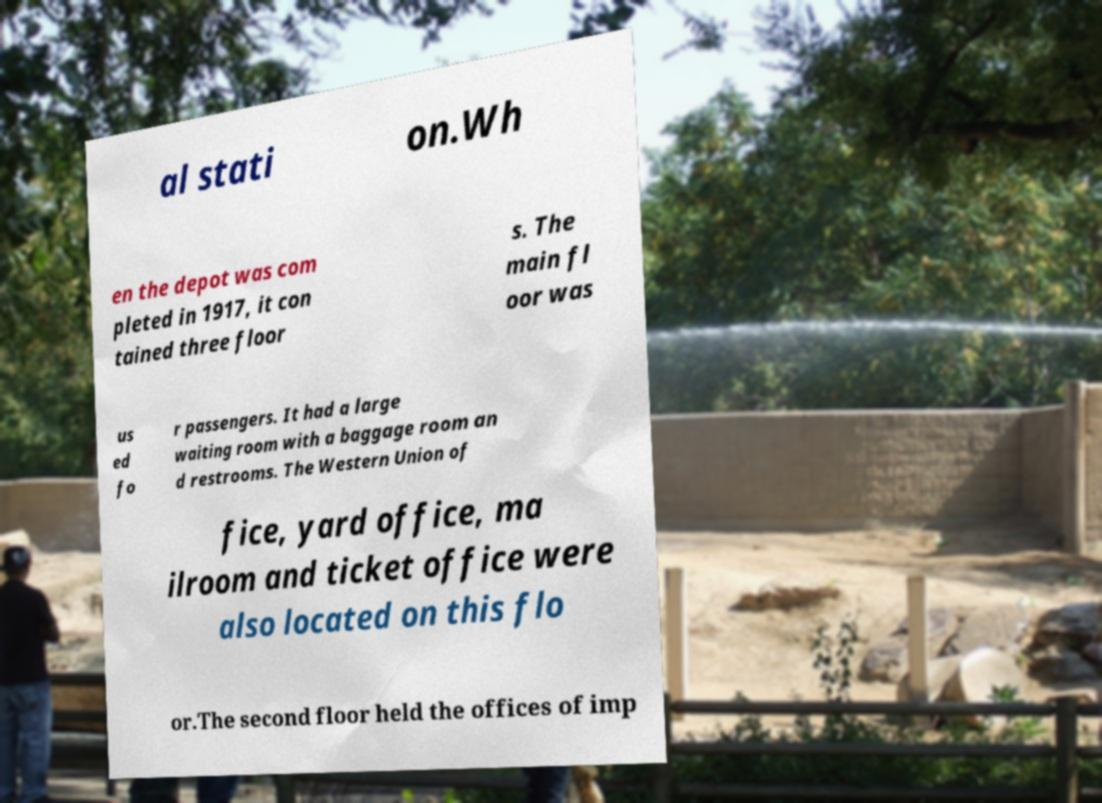Could you extract and type out the text from this image? al stati on.Wh en the depot was com pleted in 1917, it con tained three floor s. The main fl oor was us ed fo r passengers. It had a large waiting room with a baggage room an d restrooms. The Western Union of fice, yard office, ma ilroom and ticket office were also located on this flo or.The second floor held the offices of imp 